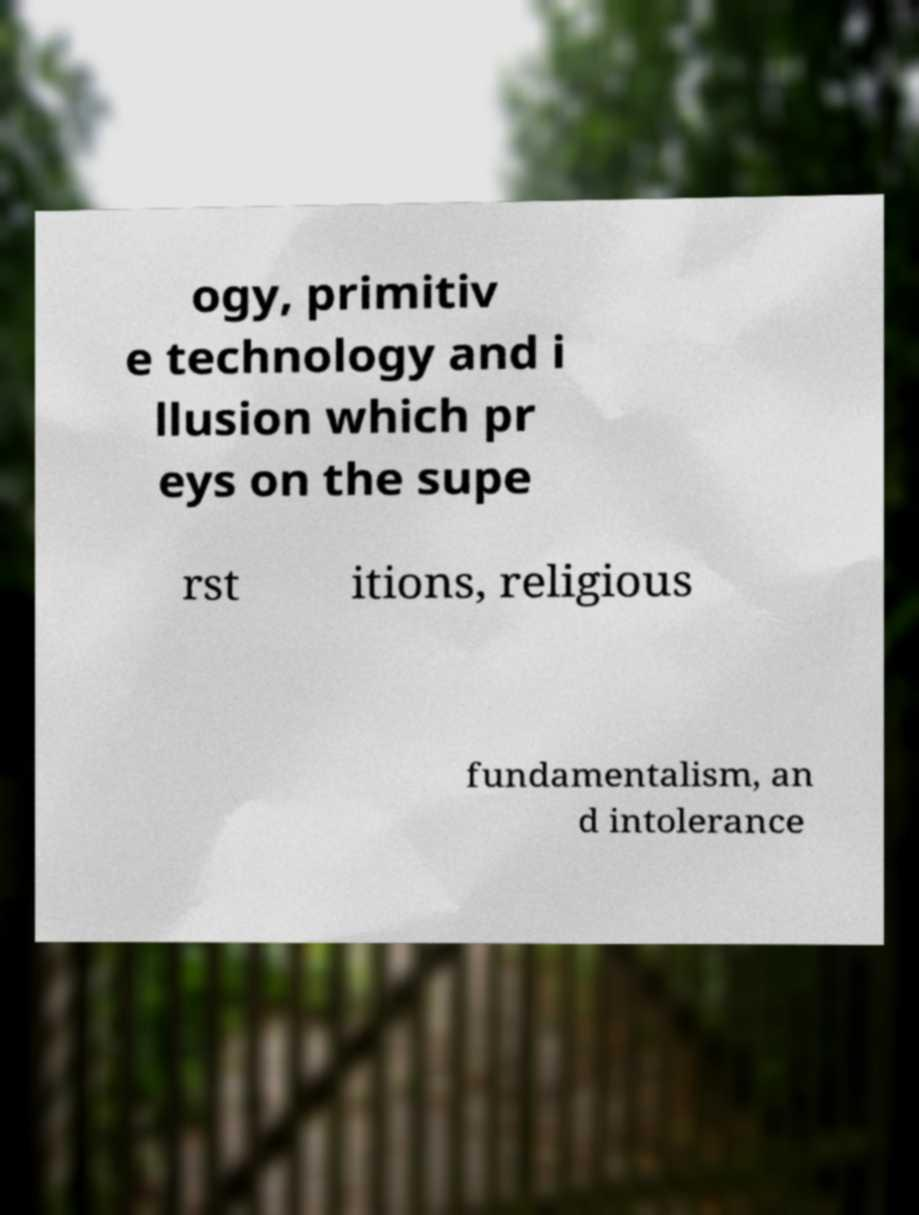I need the written content from this picture converted into text. Can you do that? ogy, primitiv e technology and i llusion which pr eys on the supe rst itions, religious fundamentalism, an d intolerance 